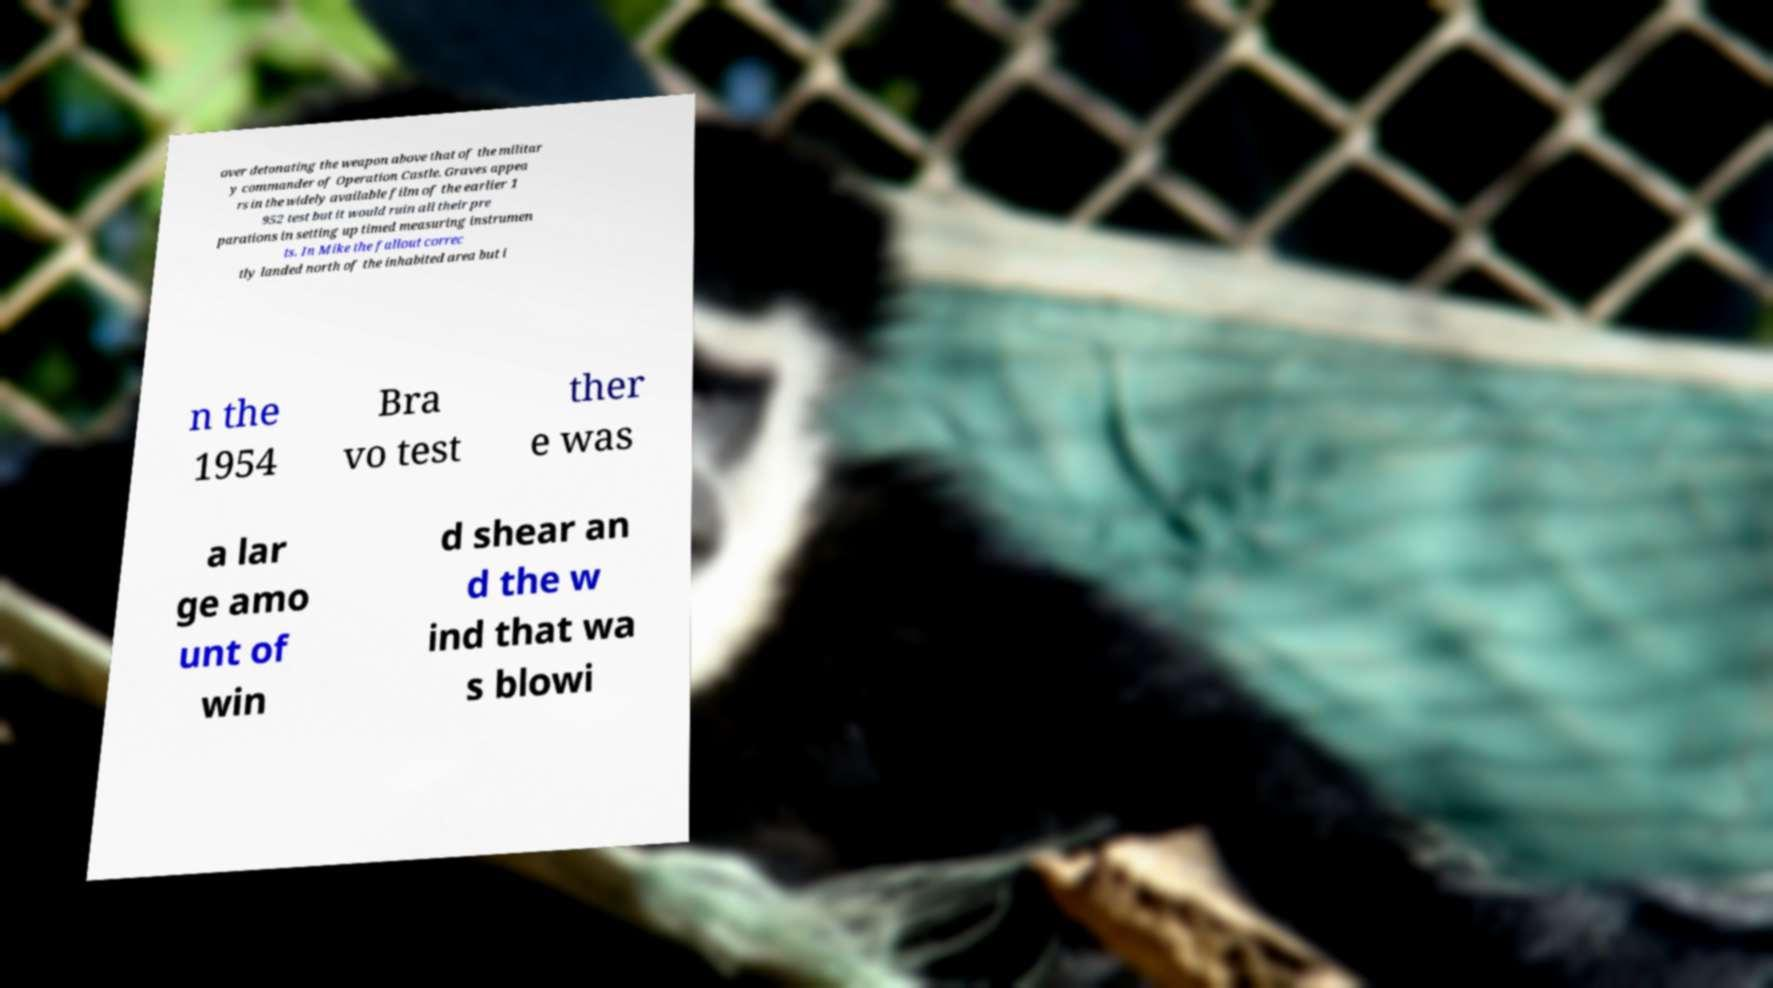There's text embedded in this image that I need extracted. Can you transcribe it verbatim? over detonating the weapon above that of the militar y commander of Operation Castle. Graves appea rs in the widely available film of the earlier 1 952 test but it would ruin all their pre parations in setting up timed measuring instrumen ts. In Mike the fallout correc tly landed north of the inhabited area but i n the 1954 Bra vo test ther e was a lar ge amo unt of win d shear an d the w ind that wa s blowi 